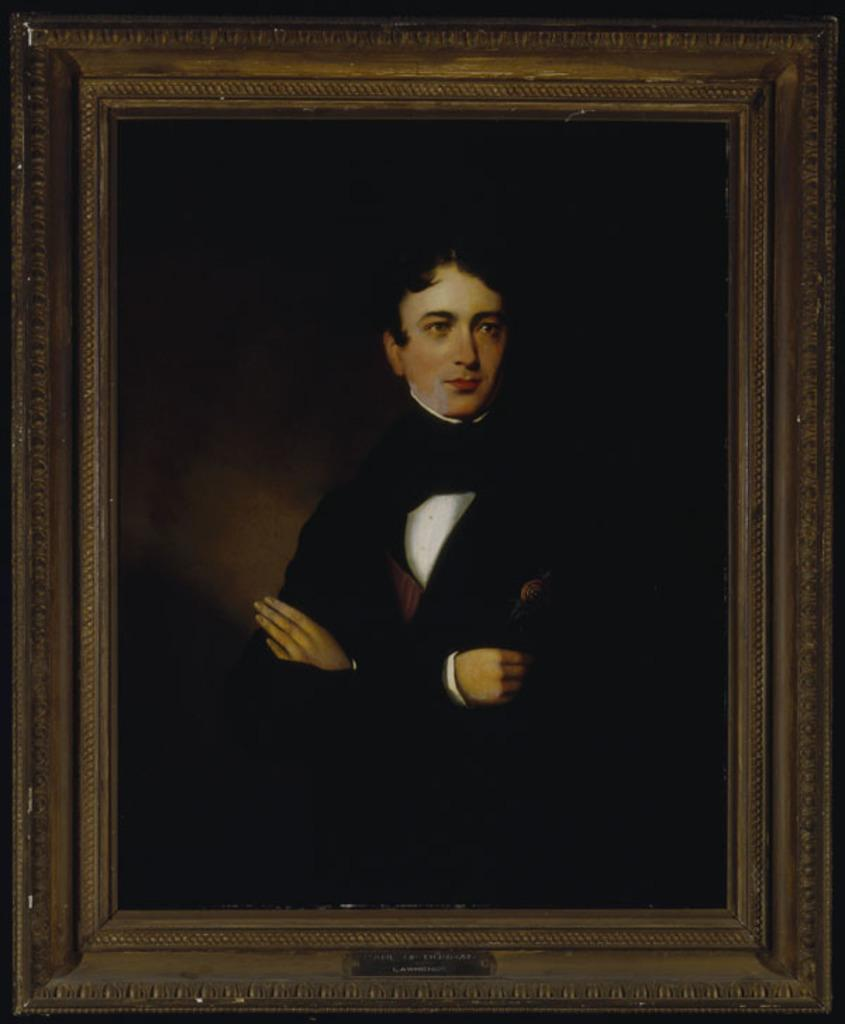What is the main object in the center of the image? There is a photo frame in the center of the image. What is inside the photo frame? The photo frame contains a picture of a person. What is the person in the photo wearing? The person in the photo is wearing a different costume. What type of tin can be seen in the background of the image? There is no tin present in the image. 